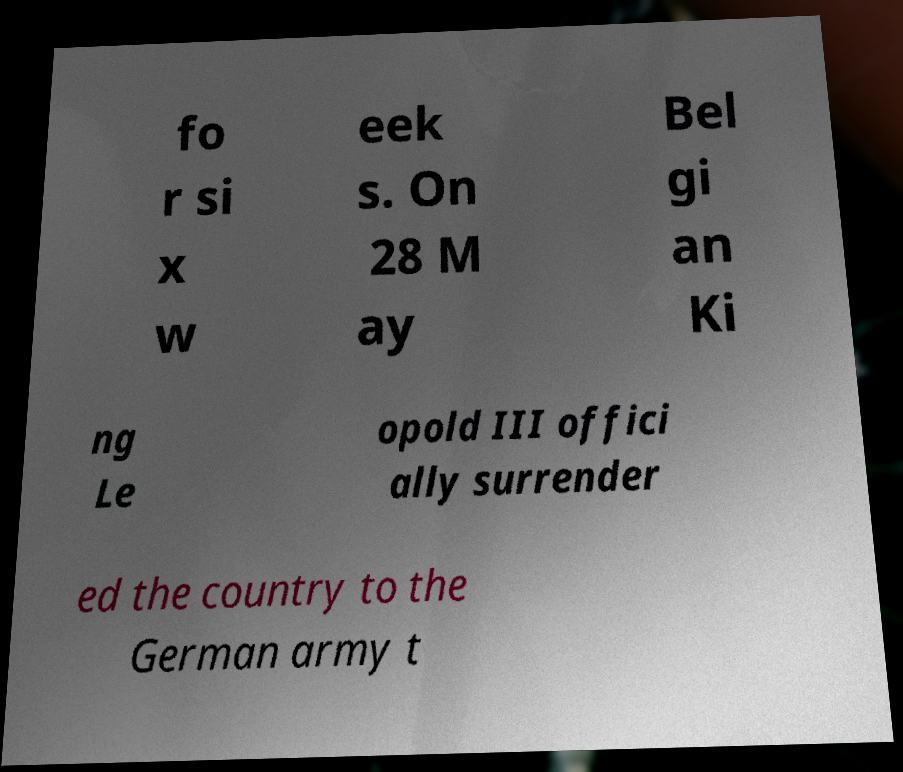Please identify and transcribe the text found in this image. fo r si x w eek s. On 28 M ay Bel gi an Ki ng Le opold III offici ally surrender ed the country to the German army t 